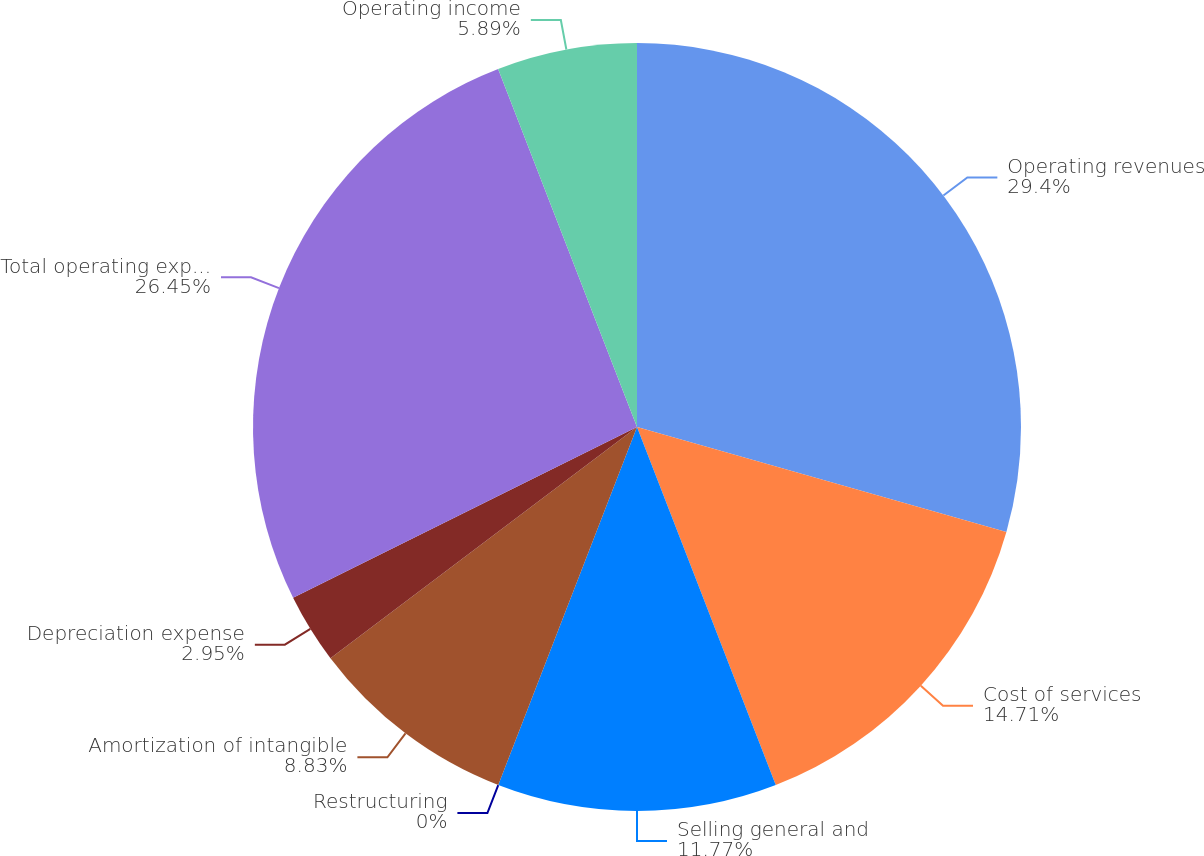<chart> <loc_0><loc_0><loc_500><loc_500><pie_chart><fcel>Operating revenues<fcel>Cost of services<fcel>Selling general and<fcel>Restructuring<fcel>Amortization of intangible<fcel>Depreciation expense<fcel>Total operating expenses<fcel>Operating income<nl><fcel>29.41%<fcel>14.71%<fcel>11.77%<fcel>0.0%<fcel>8.83%<fcel>2.95%<fcel>26.45%<fcel>5.89%<nl></chart> 